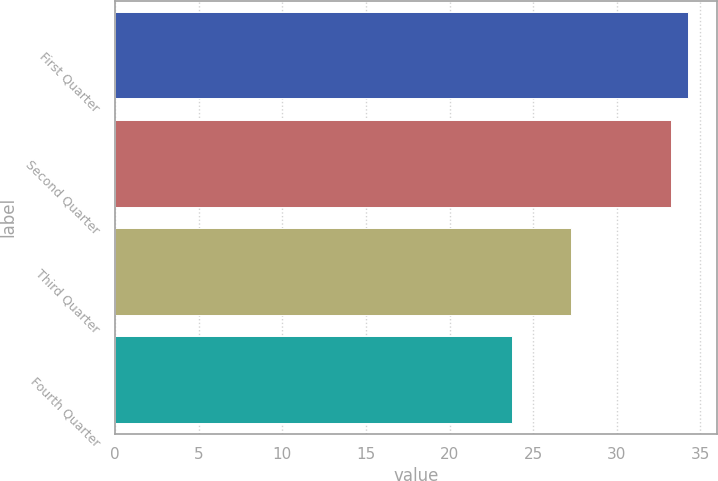Convert chart to OTSL. <chart><loc_0><loc_0><loc_500><loc_500><bar_chart><fcel>First Quarter<fcel>Second Quarter<fcel>Third Quarter<fcel>Fourth Quarter<nl><fcel>34.25<fcel>33.23<fcel>27.23<fcel>23.72<nl></chart> 